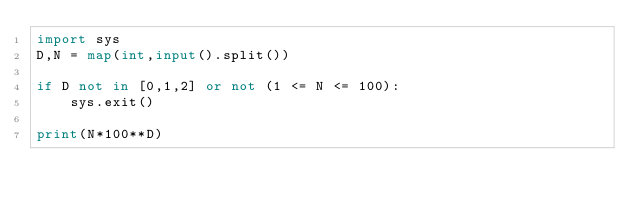Convert code to text. <code><loc_0><loc_0><loc_500><loc_500><_Python_>import sys
D,N = map(int,input().split())

if D not in [0,1,2] or not (1 <= N <= 100):
    sys.exit()

print(N*100**D)</code> 